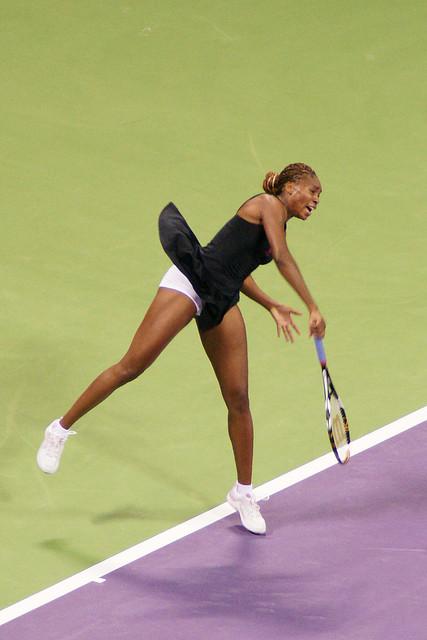What color is the court?
Give a very brief answer. Purple. Does this lady have long legs?
Concise answer only. Yes. Can you name this tennis player and her sister?
Concise answer only. Serena and venus. What sport is this lady playing?
Quick response, please. Tennis. What is the color of the woman outfit?
Give a very brief answer. Black. Does this lady need a long skirt?
Write a very short answer. No. Is she strong?
Concise answer only. Yes. 